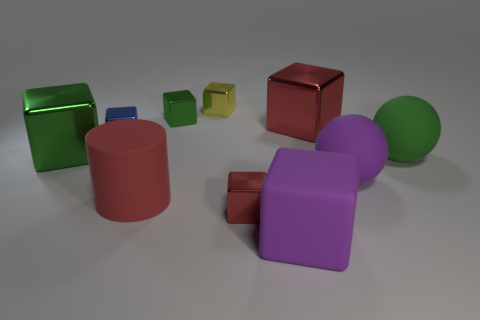Subtract all blue blocks. How many blocks are left? 6 Subtract all tiny yellow metallic cubes. How many cubes are left? 6 Subtract all gray cubes. Subtract all gray cylinders. How many cubes are left? 7 Subtract all cubes. How many objects are left? 3 Add 9 large purple rubber spheres. How many large purple rubber spheres are left? 10 Add 3 large purple spheres. How many large purple spheres exist? 4 Subtract 0 gray balls. How many objects are left? 10 Subtract all blue objects. Subtract all purple rubber objects. How many objects are left? 7 